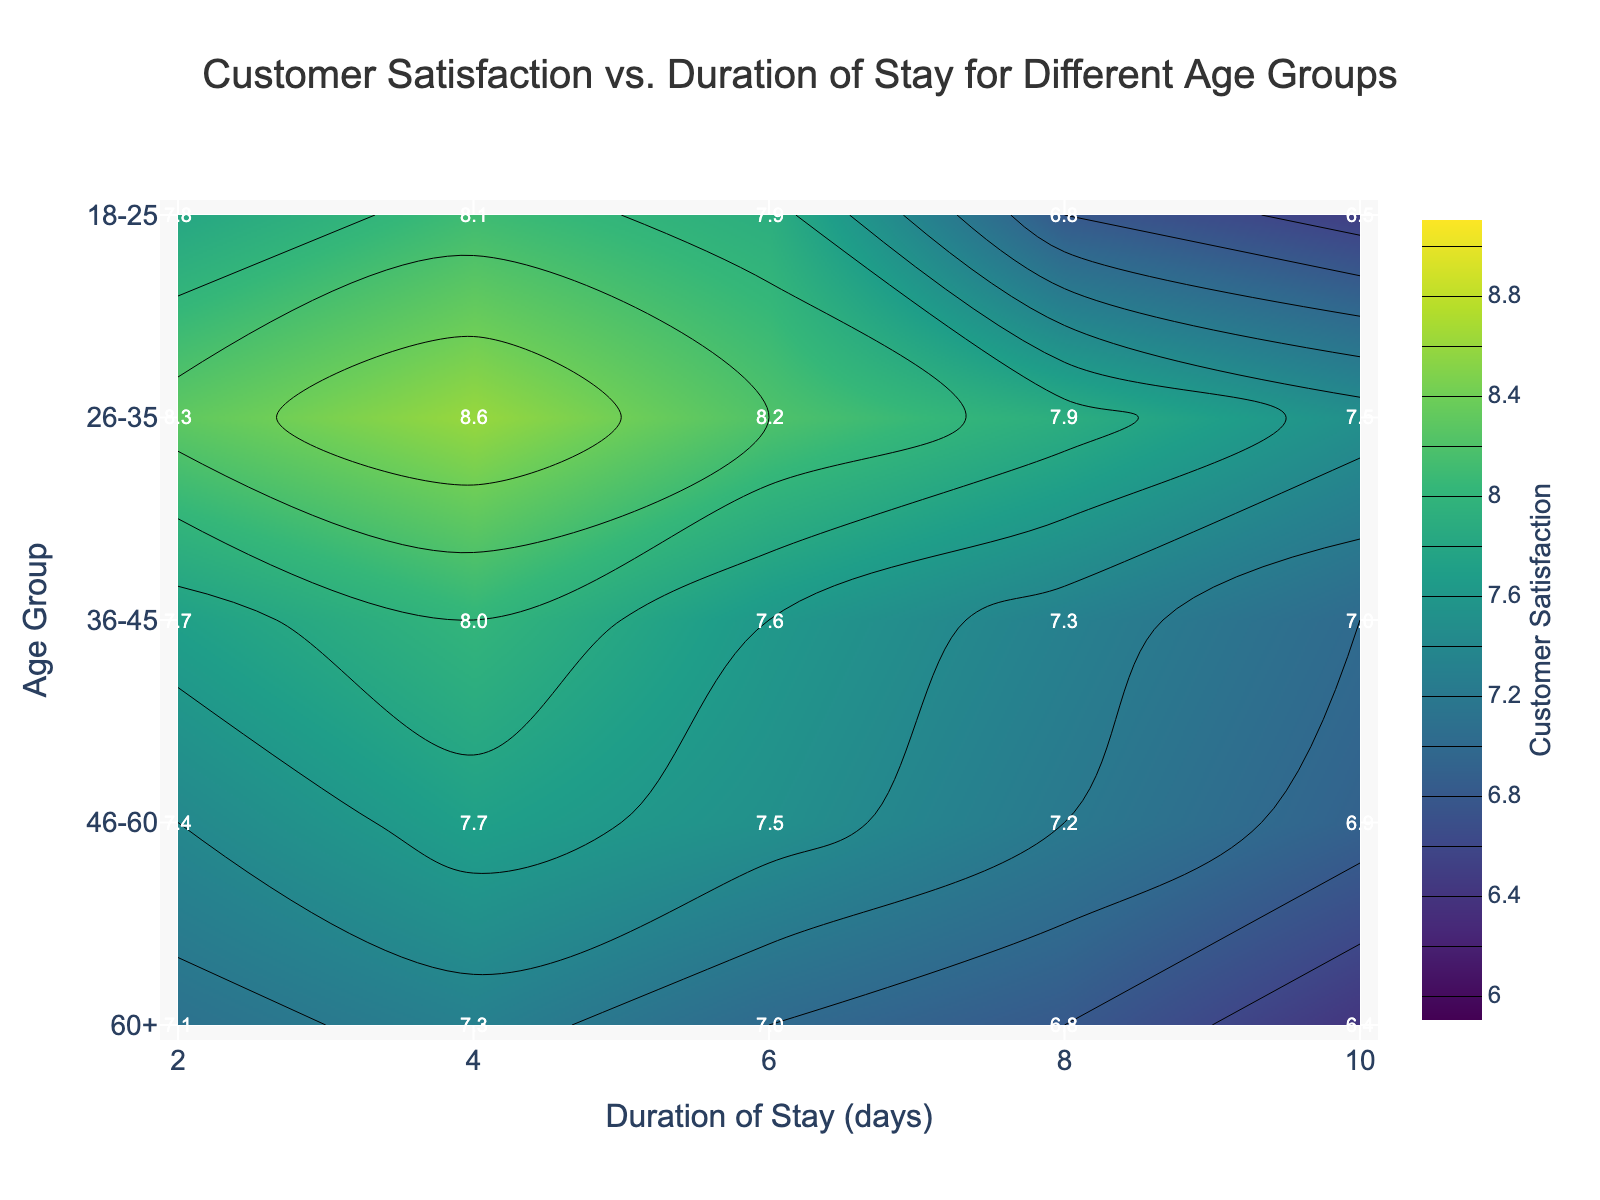What is the highest customer satisfaction for the age group 26-35? Locate the contour label corresponding to the age group 26-35. The label with the highest value is 8.6, at a 4-day duration.
Answer: 8.6 How does the customer satisfaction for the age group 18-25 change with increasing duration of stay? Observe the contour labels for the age group 18-25. Satisfaction starts at 7.8 for a 2-day stay, increases to 8.1 at 4 days, and then decreases to 6.5 at 10 days.
Answer: Decreases Which age group has the highest overall customer satisfaction for a 6-day stay? Compare the contour labels for each age group at 6 days. The highest satisfaction is 8.2 for the age group 26-35.
Answer: 26-35 For the age group 60+, how much does customer satisfaction drop from a 4-day stay to a 10-day stay? Read the satisfaction values from the labels for 4-day (7.3) and 10-day (6.4). The difference is 7.3 - 6.4.
Answer: 0.9 Which age group shows the least change in customer satisfaction across all durations of stay? Compare the range (difference between max and min satisfaction) for all age groups. 46-60 has the least range (7.7 - 6.9).
Answer: 46-60 If we want to maximize customer satisfaction, what duration of stay should be recommended for the age group 36-45? Observe the contour labels for 36-45. The highest value is 8.0 at a 4-day stay.
Answer: 4 days How does the satisfaction of age group 46-60 after an 8-day stay compare to the satisfaction of age group 18-25 after the same duration? Check the satisfaction for both groups at 8 days. 46-60 has a satisfaction of 7.2, while 18-25 has 6.8.
Answer: Higher What is the average customer satisfaction for age group 36-45 across all durations of stay? Calculate the mean of the satisfaction values: (7.7 + 8.0 + 7.6 + 7.3 + 7.0) / 5.
Answer: 7.5 Does any age group have a customer satisfaction of 8.0 or higher for all durations of stay? Check if all satisfaction values for any age group meet or exceed 8.0. No age group satisfies this criterion.
Answer: No 